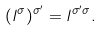<formula> <loc_0><loc_0><loc_500><loc_500>( l ^ { \sigma } ) ^ { \sigma ^ { \prime } } = l ^ { \sigma ^ { \prime } \sigma } .</formula> 